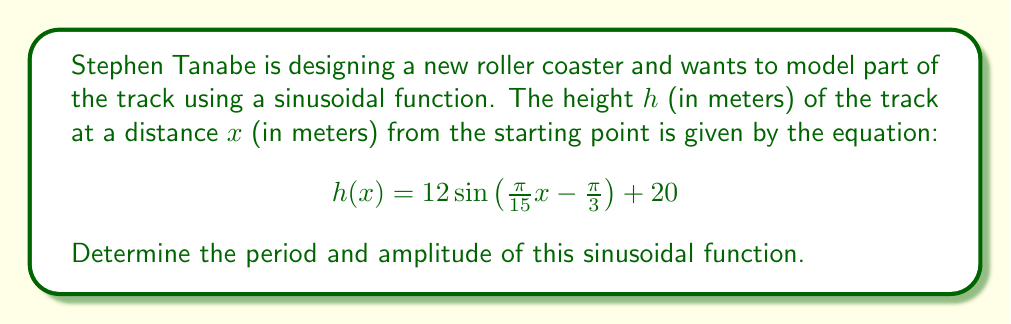Can you answer this question? To determine the period and amplitude of a sinusoidal function in the form $f(x) = A\sin(Bx - C) + D$, we use the following rules:

1. The amplitude is $|A|$.
2. The period is $\frac{2\pi}{|B|}$.

For the given function $h(x) = 12 \sin\left(\frac{\pi}{15}x - \frac{\pi}{3}\right) + 20$:

1. Amplitude:
   $A = 12$, so the amplitude is $|12| = 12$ meters.

2. Period:
   $B = \frac{\pi}{15}$
   Period = $\frac{2\pi}{|B|} = \frac{2\pi}{|\frac{\pi}{15}|} = \frac{2\pi}{\frac{\pi}{15}} = 2 \cdot 15 = 30$ meters

Therefore, the period of the function is 30 meters, and the amplitude is 12 meters.
Answer: Period: 30 m, Amplitude: 12 m 